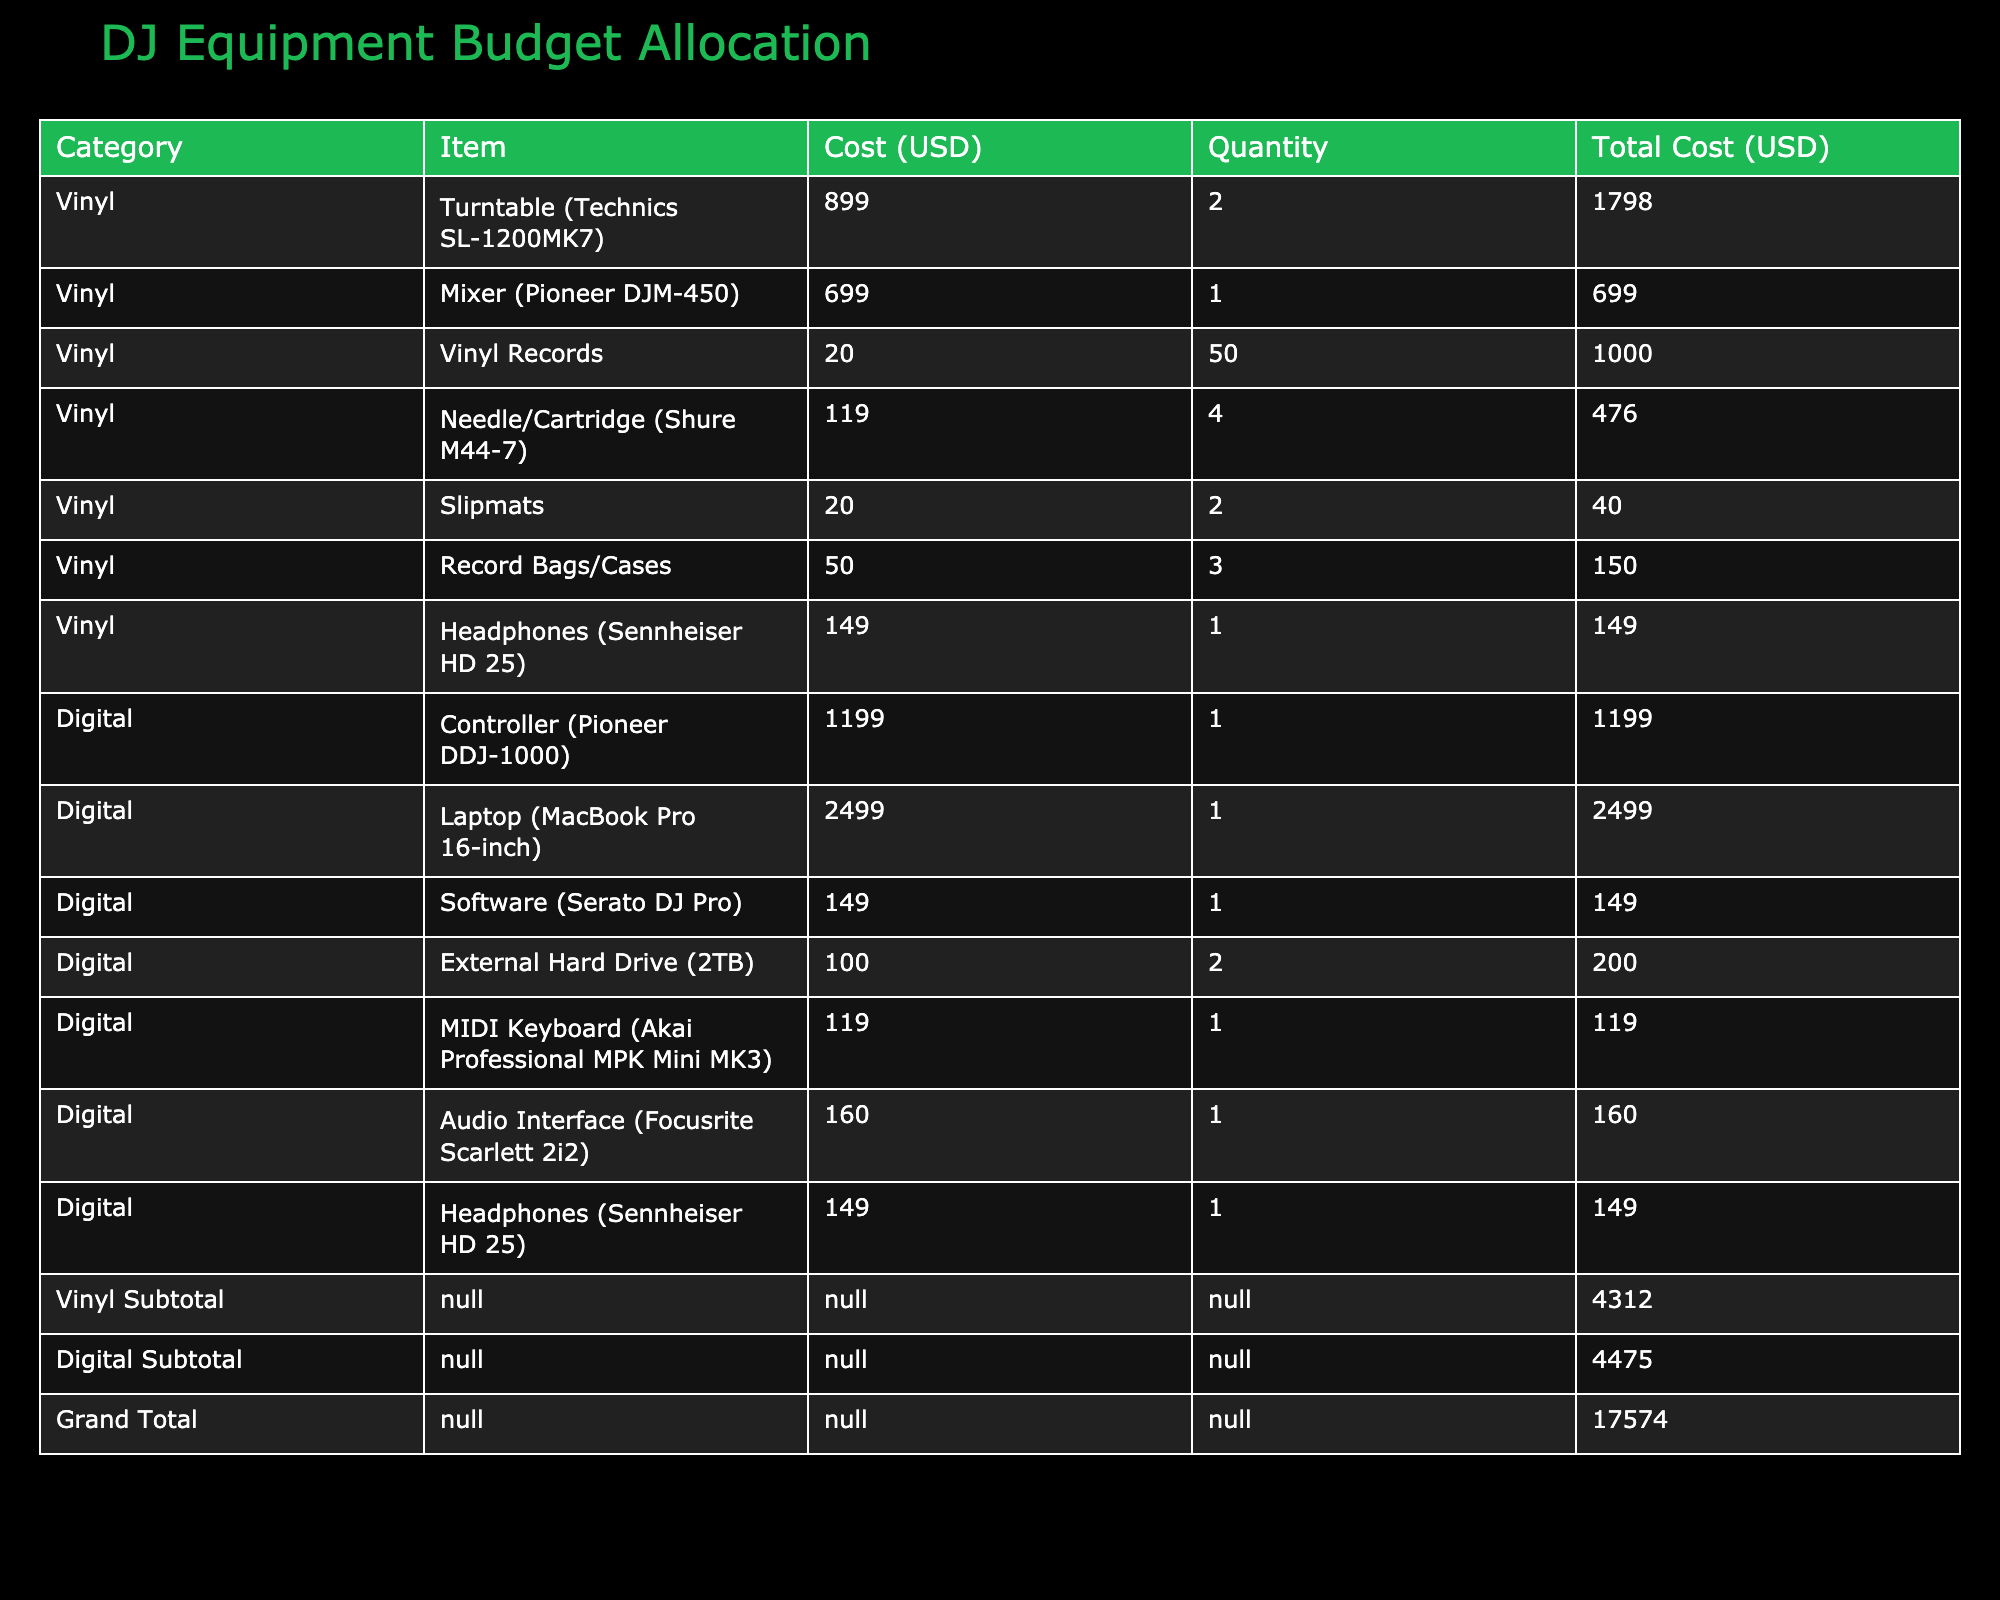What is the total cost allocated for vinyl DJ equipment? The table lists various vinyl items with their total costs. Adding these together: 1798 (turntables) + 699 (mixer) + 1000 (records) + 476 (needle/cartridge) + 40 (slipmats) + 150 (record bags) + 149 (headphones) = 3312.
Answer: 3312 What is the cost of a digital audio interface? The table shows the item costs under the digital category. The cost for the audio interface (Focusrite Scarlett 2i2) is listed as 160.
Answer: 160 Is the total cost of vinyl equipment greater than that of digital equipment? The total cost for vinyl is 3312, while for digital it is 4061 (1199 + 2499 + 149 + 200 + 119 + 160 + 149). Since 3312 is less than 4061, the answer is no.
Answer: No What is the average cost of the vinyl records? The total cost of vinyl records is 1000, and there are 50 units. To find the average: 1000 / 50 = 20.
Answer: 20 What is the total cost of all DJ equipment combined? The grand total is listed in the table as the sum of all individual totals. This can be confirmed by adding totals from both vinyl (3312) and digital (4061) categories: 3312 + 4061 = 7373.
Answer: 7373 What is the most expensive item in the digital category? In the digital category, the laptop (MacBook Pro 16-inch) is listed at 2499, which is the highest cost compared to other digital items listed.
Answer: 2499 How much more is spent on vinyl turntables than on digital controllers? The cost of turntables is 1798, while the cost of the digital controller (Pioneer DDJ-1000) is 1199. The difference is 1798 - 1199 = 599.
Answer: 599 Does the total cost for vinyl needles exceed the cost of a digital software? The total cost for the vinyl needles (Shure M44-7) is 476, and the cost for the digital software (Serato DJ Pro) is 149. Since 476 is greater than 149, the answer is yes.
Answer: Yes Which category has a higher subtotal, vinyl or digital? According to the table, the subtotal for vinyl is 3312 and for digital is 4061. Since the digital subtotal (4061) is greater than the vinyl subtotal (3312), the answer is digital.
Answer: Digital 